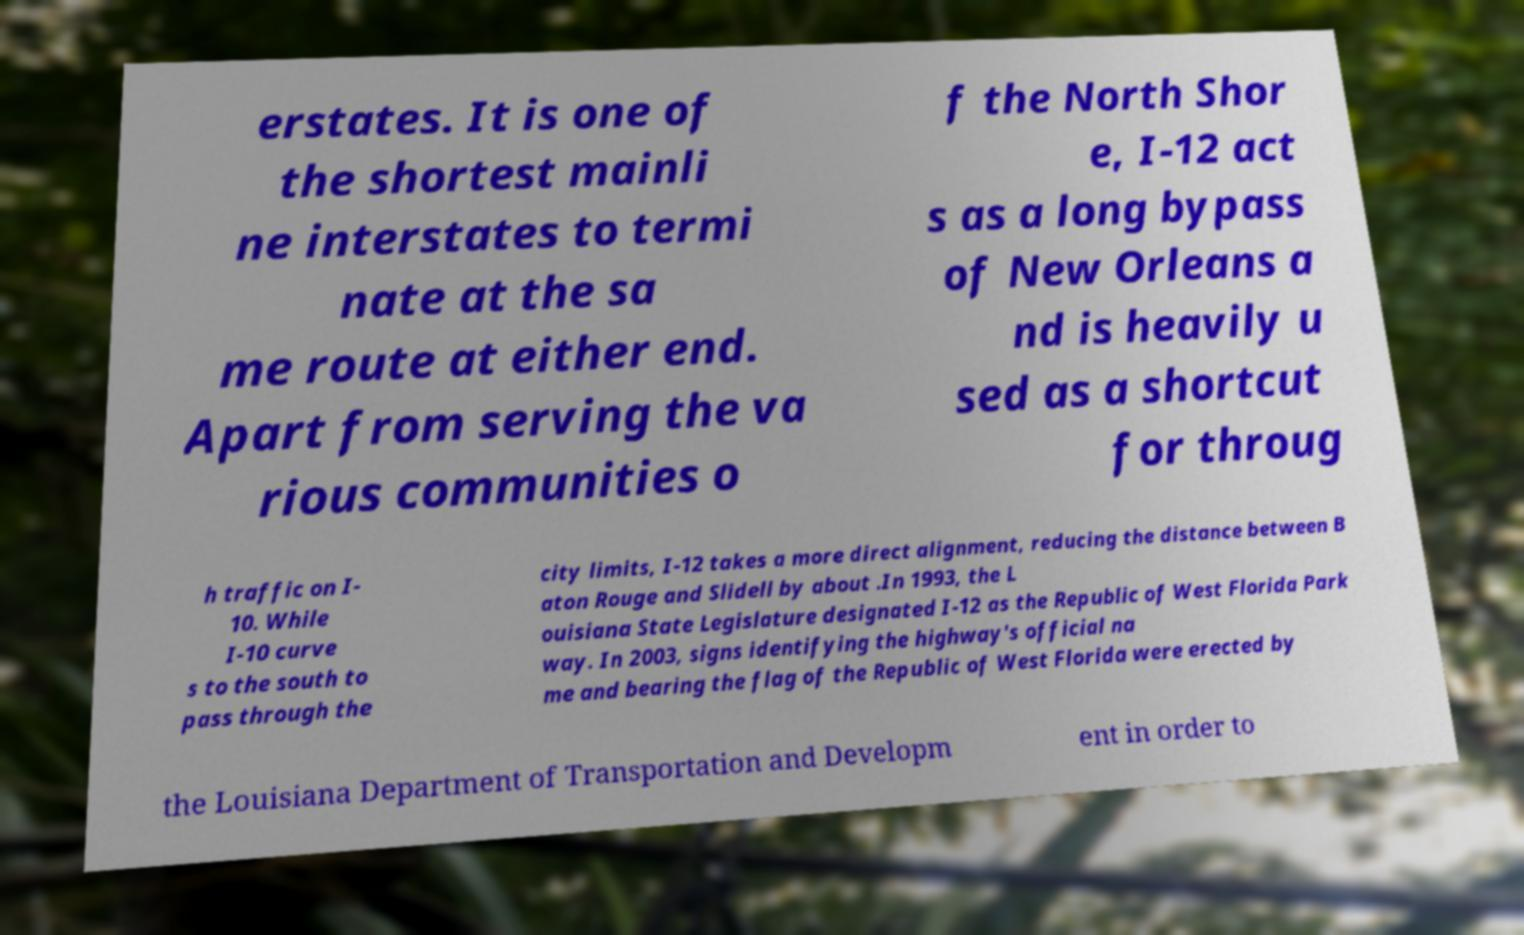I need the written content from this picture converted into text. Can you do that? erstates. It is one of the shortest mainli ne interstates to termi nate at the sa me route at either end. Apart from serving the va rious communities o f the North Shor e, I-12 act s as a long bypass of New Orleans a nd is heavily u sed as a shortcut for throug h traffic on I- 10. While I-10 curve s to the south to pass through the city limits, I-12 takes a more direct alignment, reducing the distance between B aton Rouge and Slidell by about .In 1993, the L ouisiana State Legislature designated I-12 as the Republic of West Florida Park way. In 2003, signs identifying the highway's official na me and bearing the flag of the Republic of West Florida were erected by the Louisiana Department of Transportation and Developm ent in order to 